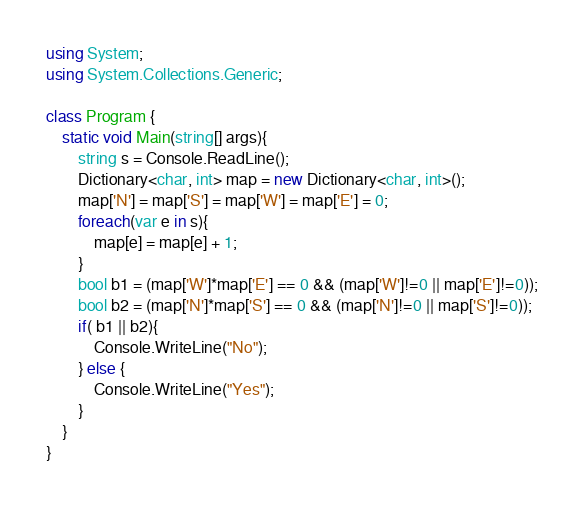<code> <loc_0><loc_0><loc_500><loc_500><_C#_>using System;
using System.Collections.Generic;

class Program {
    static void Main(string[] args){
        string s = Console.ReadLine();
        Dictionary<char, int> map = new Dictionary<char, int>();
        map['N'] = map['S'] = map['W'] = map['E'] = 0; 
        foreach(var e in s){
            map[e] = map[e] + 1;
        }
        bool b1 = (map['W']*map['E'] == 0 && (map['W']!=0 || map['E']!=0));
        bool b2 = (map['N']*map['S'] == 0 && (map['N']!=0 || map['S']!=0));
        if( b1 || b2){
            Console.WriteLine("No");
        } else {
            Console.WriteLine("Yes");
        }
    }
}</code> 